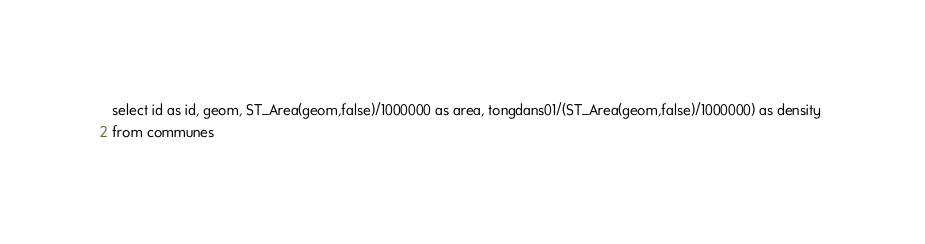Convert code to text. <code><loc_0><loc_0><loc_500><loc_500><_SQL_>select id as id, geom, ST_Area(geom,false)/1000000 as area, tongdans01/(ST_Area(geom,false)/1000000) as density 
from communes</code> 